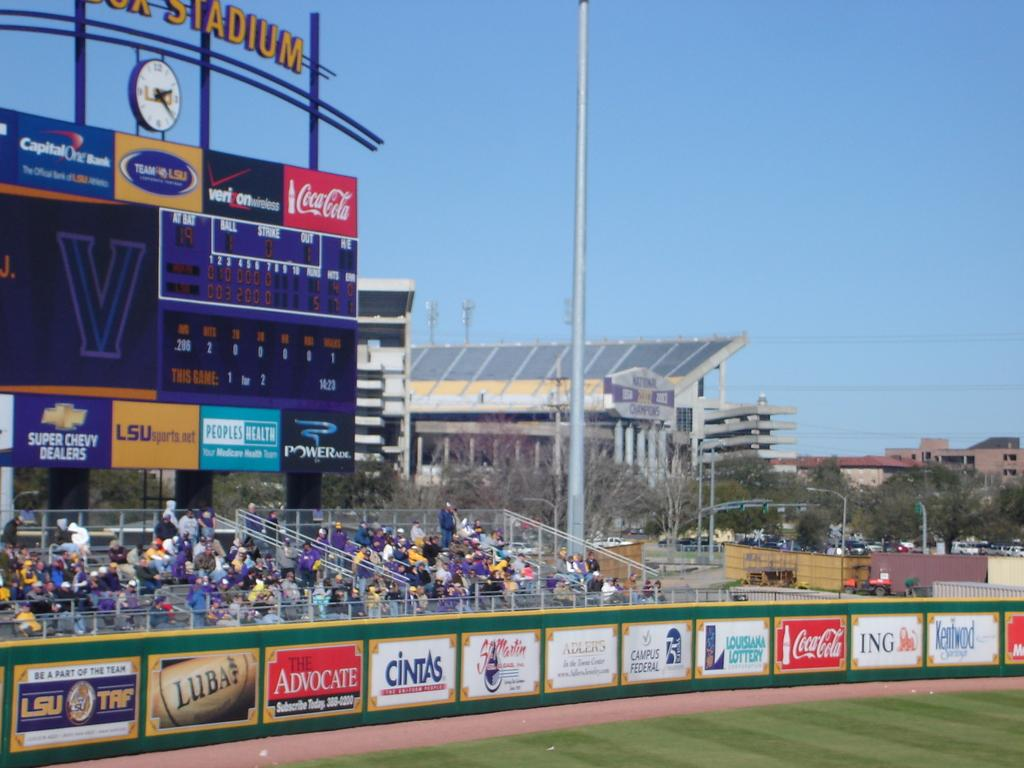<image>
Write a terse but informative summary of the picture. The fence around the field at LSU's stadium is filled with ads including Coke and Cintas. 